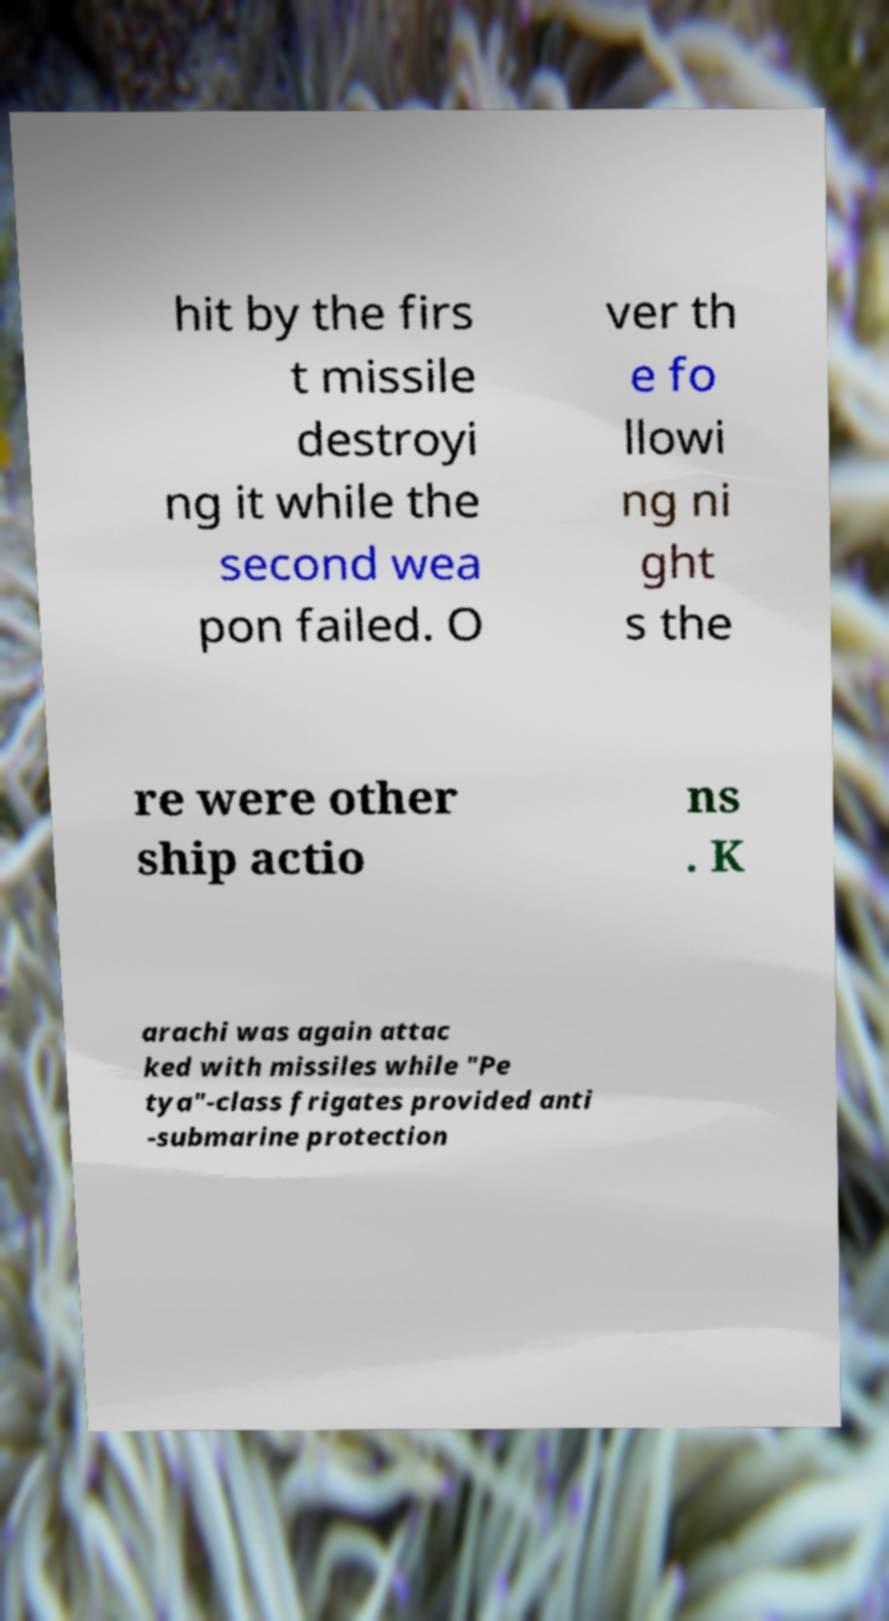Could you assist in decoding the text presented in this image and type it out clearly? hit by the firs t missile destroyi ng it while the second wea pon failed. O ver th e fo llowi ng ni ght s the re were other ship actio ns . K arachi was again attac ked with missiles while "Pe tya"-class frigates provided anti -submarine protection 